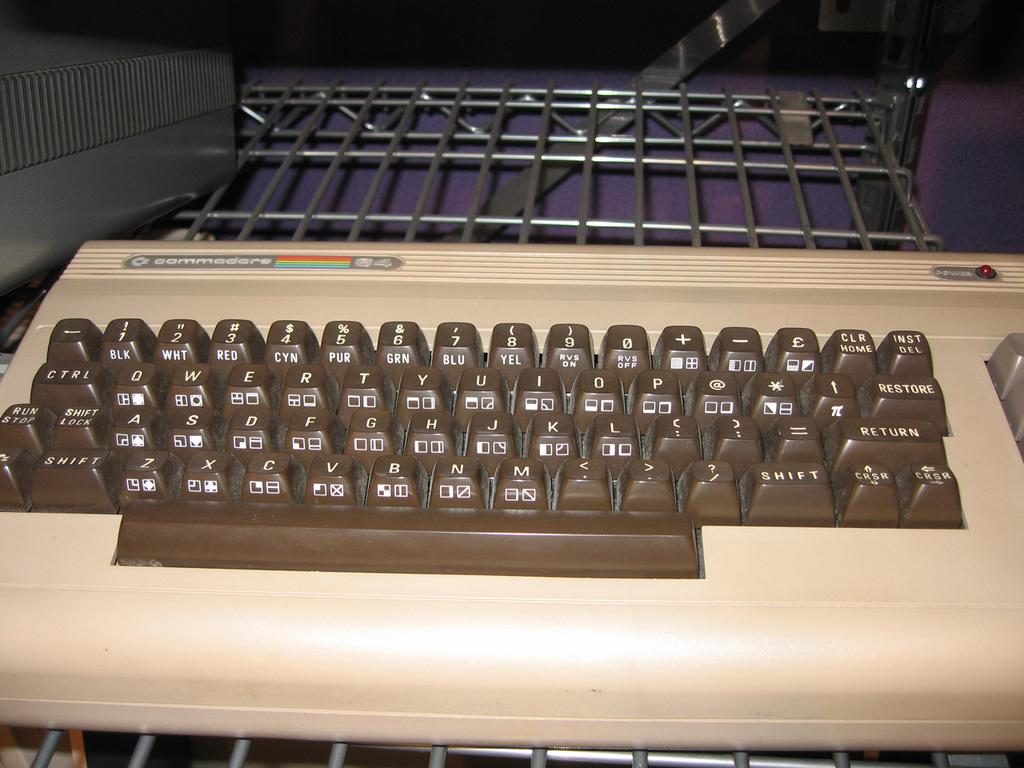<image>
Describe the image concisely. The brown and tan keyboard is an old Commodore 